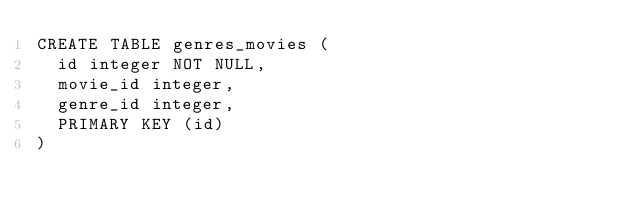<code> <loc_0><loc_0><loc_500><loc_500><_SQL_>CREATE TABLE genres_movies (
  id integer NOT NULL,
  movie_id integer,
  genre_id integer,
  PRIMARY KEY (id)
)
</code> 